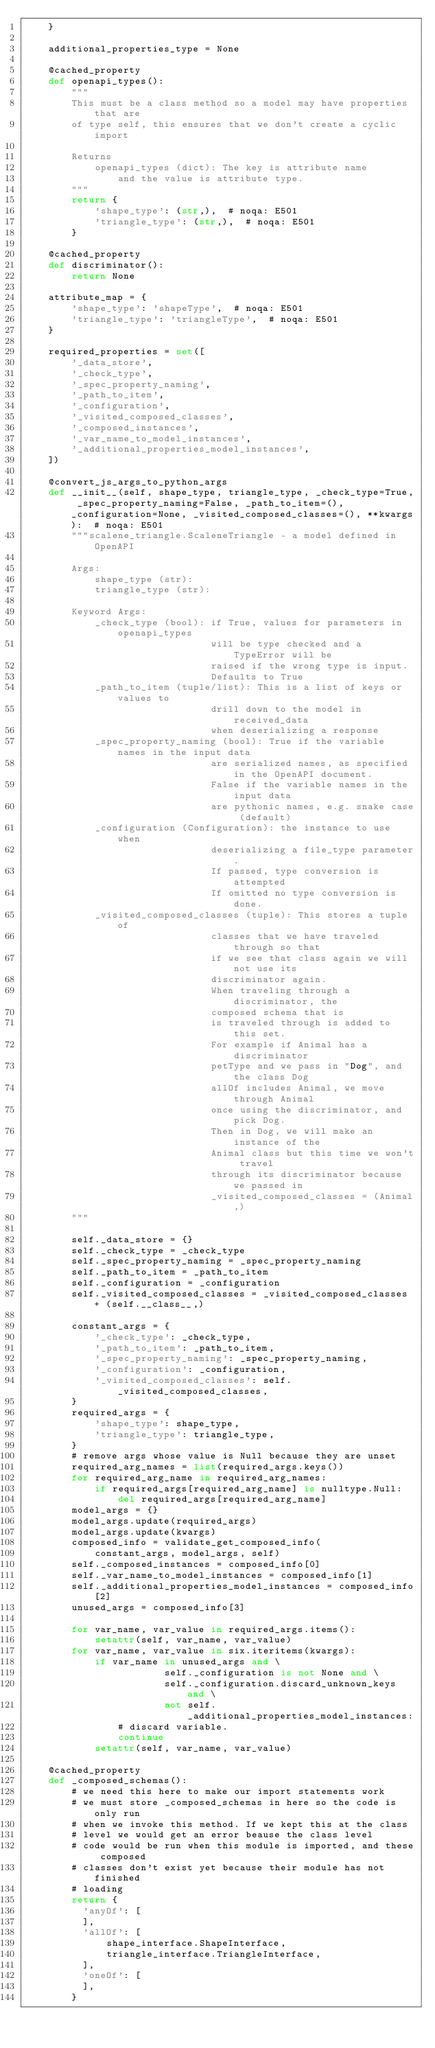<code> <loc_0><loc_0><loc_500><loc_500><_Python_>    }

    additional_properties_type = None

    @cached_property
    def openapi_types():
        """
        This must be a class method so a model may have properties that are
        of type self, this ensures that we don't create a cyclic import

        Returns
            openapi_types (dict): The key is attribute name
                and the value is attribute type.
        """
        return {
            'shape_type': (str,),  # noqa: E501
            'triangle_type': (str,),  # noqa: E501
        }

    @cached_property
    def discriminator():
        return None

    attribute_map = {
        'shape_type': 'shapeType',  # noqa: E501
        'triangle_type': 'triangleType',  # noqa: E501
    }

    required_properties = set([
        '_data_store',
        '_check_type',
        '_spec_property_naming',
        '_path_to_item',
        '_configuration',
        '_visited_composed_classes',
        '_composed_instances',
        '_var_name_to_model_instances',
        '_additional_properties_model_instances',
    ])

    @convert_js_args_to_python_args
    def __init__(self, shape_type, triangle_type, _check_type=True, _spec_property_naming=False, _path_to_item=(), _configuration=None, _visited_composed_classes=(), **kwargs):  # noqa: E501
        """scalene_triangle.ScaleneTriangle - a model defined in OpenAPI

        Args:
            shape_type (str):
            triangle_type (str):

        Keyword Args:
            _check_type (bool): if True, values for parameters in openapi_types
                                will be type checked and a TypeError will be
                                raised if the wrong type is input.
                                Defaults to True
            _path_to_item (tuple/list): This is a list of keys or values to
                                drill down to the model in received_data
                                when deserializing a response
            _spec_property_naming (bool): True if the variable names in the input data
                                are serialized names, as specified in the OpenAPI document.
                                False if the variable names in the input data
                                are pythonic names, e.g. snake case (default)
            _configuration (Configuration): the instance to use when
                                deserializing a file_type parameter.
                                If passed, type conversion is attempted
                                If omitted no type conversion is done.
            _visited_composed_classes (tuple): This stores a tuple of
                                classes that we have traveled through so that
                                if we see that class again we will not use its
                                discriminator again.
                                When traveling through a discriminator, the
                                composed schema that is
                                is traveled through is added to this set.
                                For example if Animal has a discriminator
                                petType and we pass in "Dog", and the class Dog
                                allOf includes Animal, we move through Animal
                                once using the discriminator, and pick Dog.
                                Then in Dog, we will make an instance of the
                                Animal class but this time we won't travel
                                through its discriminator because we passed in
                                _visited_composed_classes = (Animal,)
        """

        self._data_store = {}
        self._check_type = _check_type
        self._spec_property_naming = _spec_property_naming
        self._path_to_item = _path_to_item
        self._configuration = _configuration
        self._visited_composed_classes = _visited_composed_classes + (self.__class__,)

        constant_args = {
            '_check_type': _check_type,
            '_path_to_item': _path_to_item,
            '_spec_property_naming': _spec_property_naming,
            '_configuration': _configuration,
            '_visited_composed_classes': self._visited_composed_classes,
        }
        required_args = {
            'shape_type': shape_type,
            'triangle_type': triangle_type,
        }
        # remove args whose value is Null because they are unset
        required_arg_names = list(required_args.keys())
        for required_arg_name in required_arg_names:
            if required_args[required_arg_name] is nulltype.Null:
                del required_args[required_arg_name]
        model_args = {}
        model_args.update(required_args)
        model_args.update(kwargs)
        composed_info = validate_get_composed_info(
            constant_args, model_args, self)
        self._composed_instances = composed_info[0]
        self._var_name_to_model_instances = composed_info[1]
        self._additional_properties_model_instances = composed_info[2]
        unused_args = composed_info[3]

        for var_name, var_value in required_args.items():
            setattr(self, var_name, var_value)
        for var_name, var_value in six.iteritems(kwargs):
            if var_name in unused_args and \
                        self._configuration is not None and \
                        self._configuration.discard_unknown_keys and \
                        not self._additional_properties_model_instances:
                # discard variable.
                continue
            setattr(self, var_name, var_value)

    @cached_property
    def _composed_schemas():
        # we need this here to make our import statements work
        # we must store _composed_schemas in here so the code is only run
        # when we invoke this method. If we kept this at the class
        # level we would get an error beause the class level
        # code would be run when this module is imported, and these composed
        # classes don't exist yet because their module has not finished
        # loading
        return {
          'anyOf': [
          ],
          'allOf': [
              shape_interface.ShapeInterface,
              triangle_interface.TriangleInterface,
          ],
          'oneOf': [
          ],
        }
</code> 